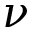Convert formula to latex. <formula><loc_0><loc_0><loc_500><loc_500>\nu</formula> 